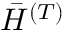<formula> <loc_0><loc_0><loc_500><loc_500>\bar { H } ^ { ( T ) }</formula> 